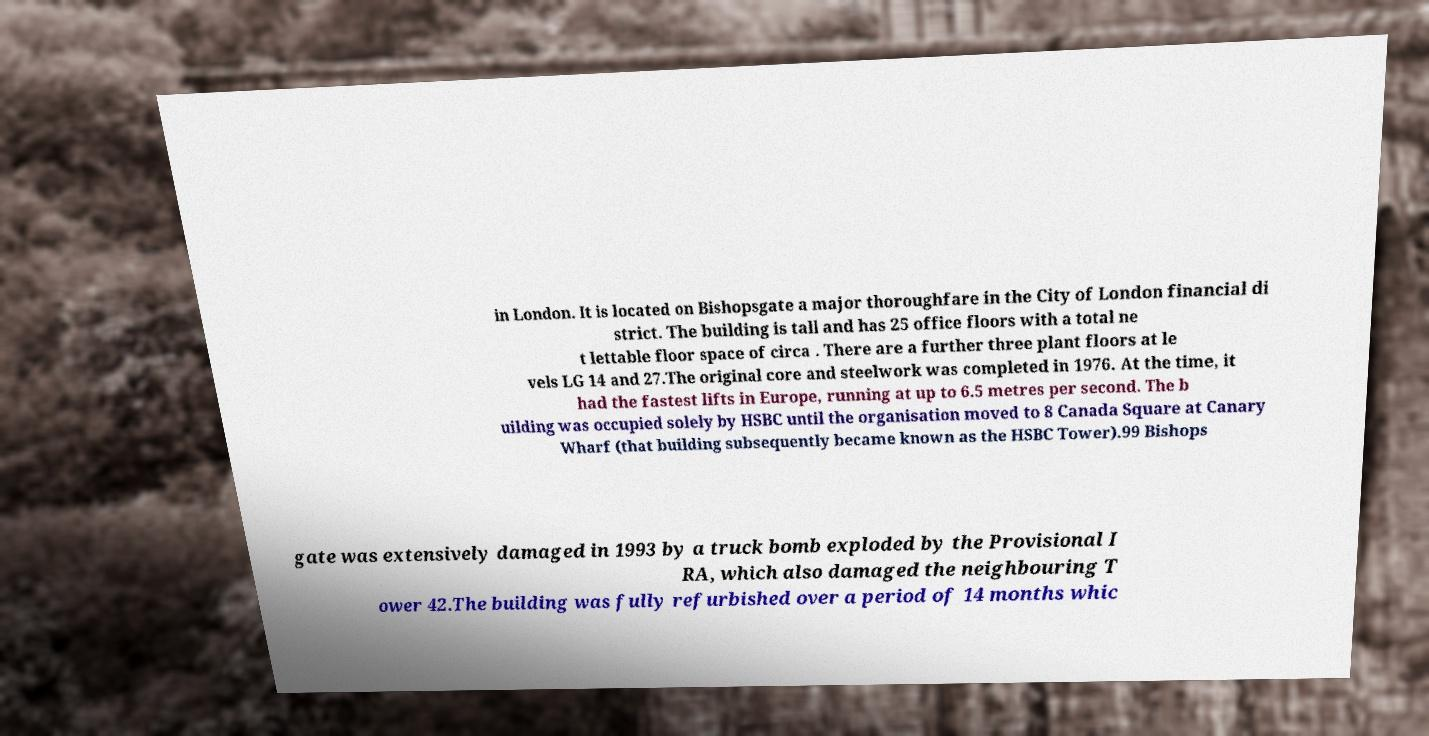Please read and relay the text visible in this image. What does it say? in London. It is located on Bishopsgate a major thoroughfare in the City of London financial di strict. The building is tall and has 25 office floors with a total ne t lettable floor space of circa . There are a further three plant floors at le vels LG 14 and 27.The original core and steelwork was completed in 1976. At the time, it had the fastest lifts in Europe, running at up to 6.5 metres per second. The b uilding was occupied solely by HSBC until the organisation moved to 8 Canada Square at Canary Wharf (that building subsequently became known as the HSBC Tower).99 Bishops gate was extensively damaged in 1993 by a truck bomb exploded by the Provisional I RA, which also damaged the neighbouring T ower 42.The building was fully refurbished over a period of 14 months whic 